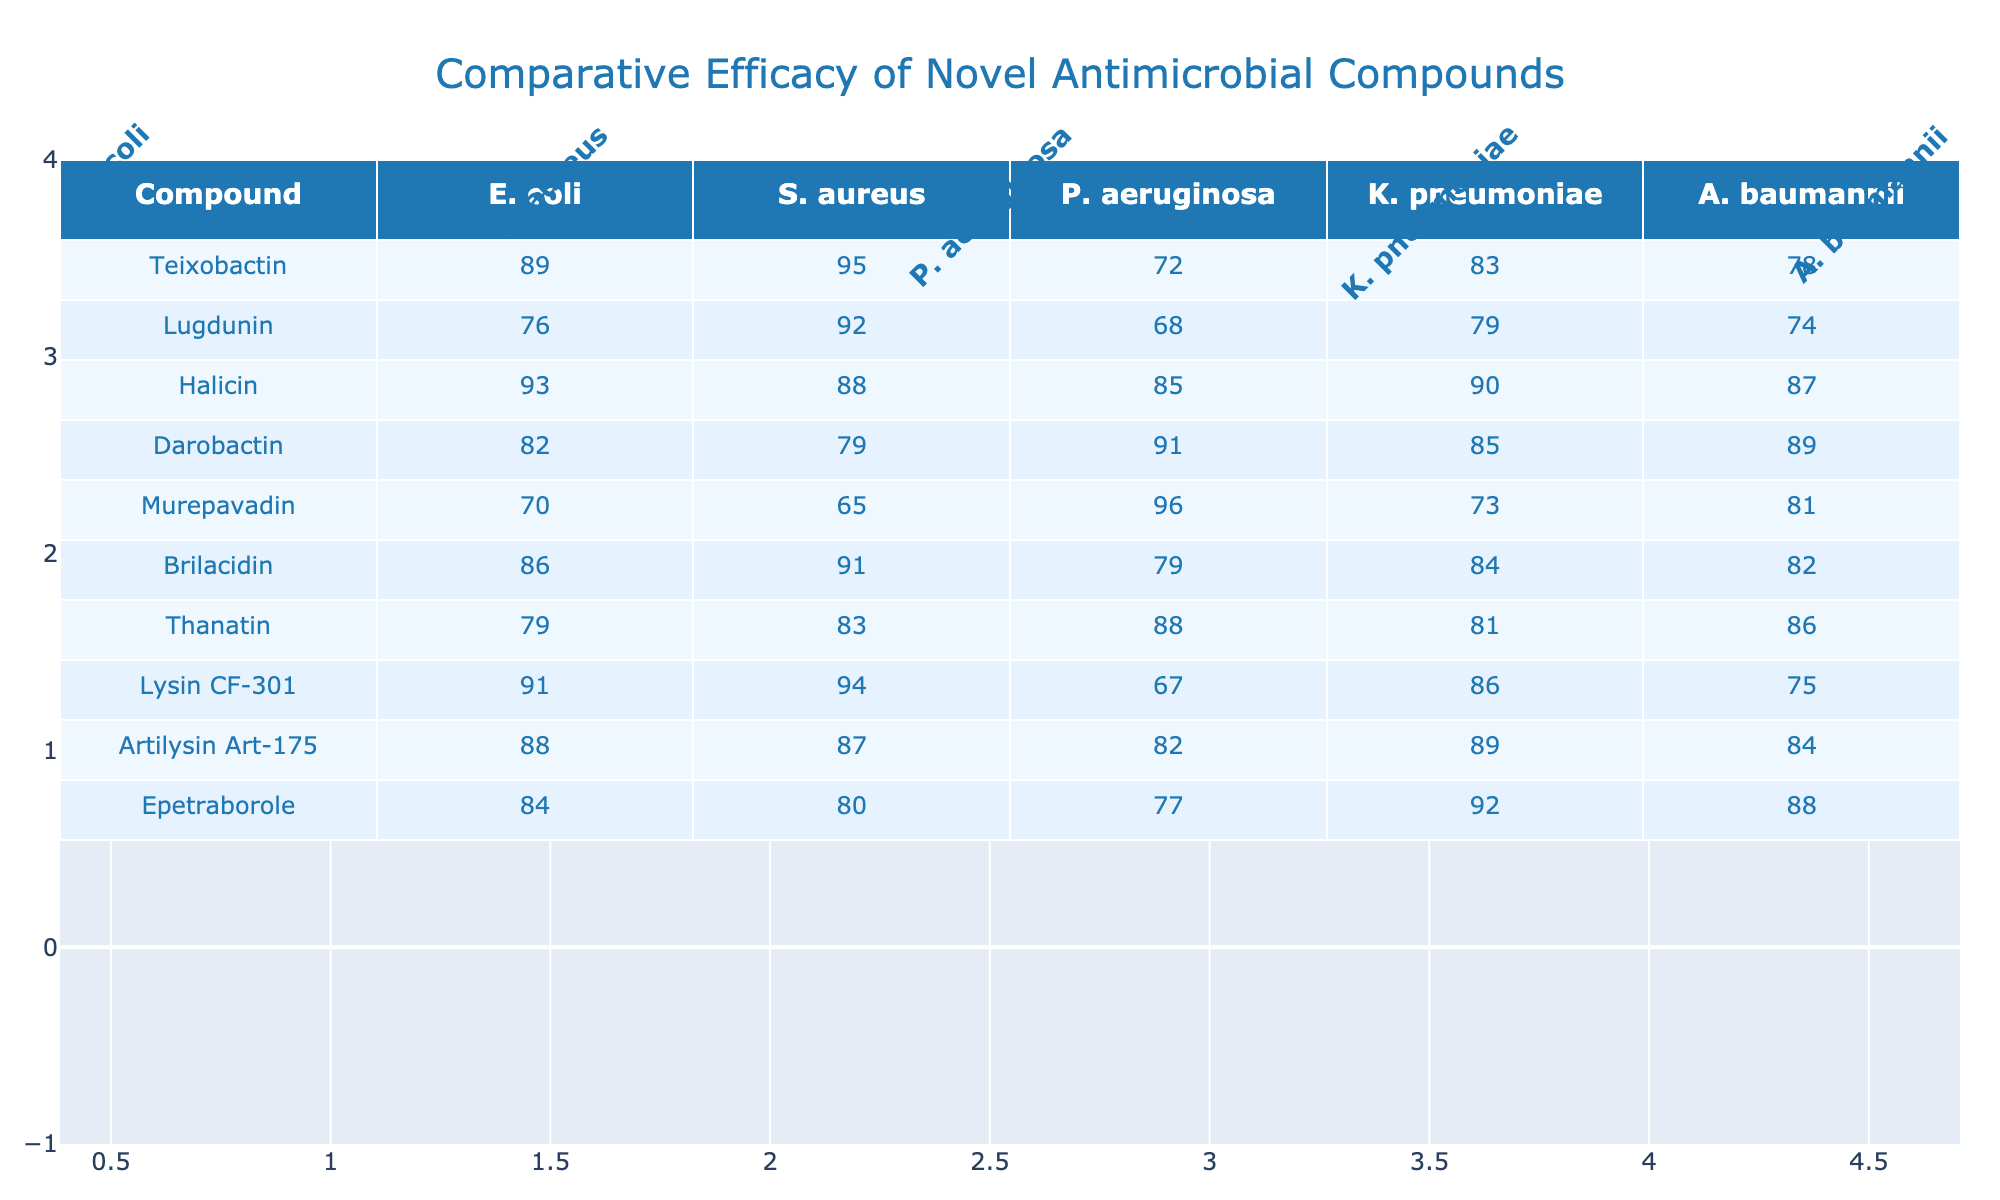What is the efficacy of Halicin against S. aureus? The table indicates that Halicin has an efficacy of 88 against S. aureus.
Answer: 88 Which compound shows the highest efficacy against E. coli? Looking at the E. coli column, Teixobactin has the highest efficacy at 89.
Answer: Teixobactin What is the average efficacy of compounds against K. pneumoniae? To find the average, sum the efficacies of all compounds against K. pneumoniae: (83 + 79 + 90 + 85 + 73 + 84 + 81 + 86 + 89 + 92) =  840. Divide by the number of compounds (10), so the average is 840/10 = 84.
Answer: 84 Does Lugdunin have a higher efficacy against A. baumannii than Murepavadin? Lugdunin has an efficacy of 74 against A. baumannii, while Murepavadin has 81. Since 74 is less than 81, Lugdunin does not have a higher efficacy.
Answer: No Which compound has the lowest efficacy against P. aeruginosa? The efficacy values for P. aeruginosa are: 72 (Teixobactin), 68 (Lugdunin), 85 (Halicin), 91 (Darobactin), 96 (Murepavadin), 79 (Brilacidin), 88 (Thanatin), 67 (Lysin CF-301), 82 (Artilysin Art-175), and 77 (Epetraborole). The lowest value is 67 from Lysin CF-301.
Answer: Lysin CF-301 What is the difference in efficacy against S. aureus between Teixobactin and Darobactin? Teixobactin has an efficacy of 95 and Darobactin has 79. The difference is 95 - 79 = 16.
Answer: 16 Which compound is most consistently effective across all bacterial strains? To determine this, compare the efficacies: Halicin (93, 88, 85, 90, 87), being high across the board without any drastic drops. Other compounds have lower values in at least one strain.
Answer: Halicin Is it true that Murepavadin shows the highest efficacy against K. pneumoniae? Murepavadin has an efficacy of 73 against K. pneumoniae, while other compounds show higher values (Teixobactin 83, Lugdunin 79, Halicin 90, etc.). Therefore, this statement is false.
Answer: No Which compound has a significantly lower efficacy against E. coli compared to the average of all compounds? The average efficacy against E. coli is (89 + 76 + 93 + 82 + 70 + 86 + 79 + 91 + 88 + 84) = 83.7. Murepavadin with an efficacy of 70 is lower than this average, thus it qualifies.
Answer: Murepavadin What is the highest efficacy against A. baumannii among the compounds? In the A. baumannii column, Halicin scores the highest at 87, compared to others like Teixobactin (78), Lugdunin (74), etc.
Answer: Halicin 